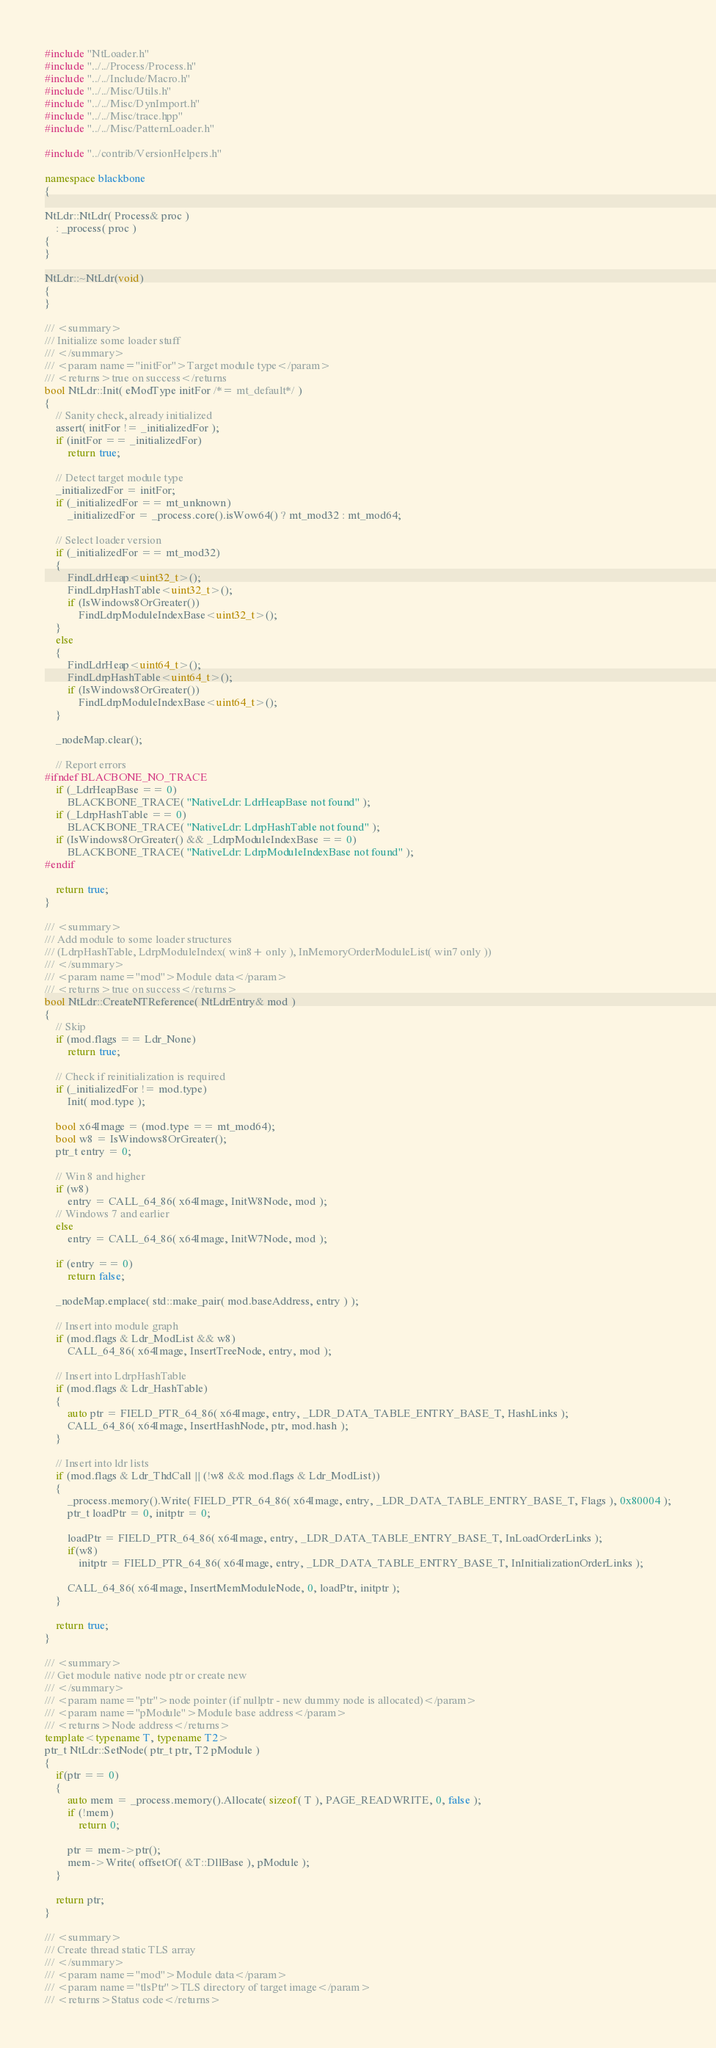Convert code to text. <code><loc_0><loc_0><loc_500><loc_500><_C++_>#include "NtLoader.h"
#include "../../Process/Process.h"
#include "../../Include/Macro.h"
#include "../../Misc/Utils.h"
#include "../../Misc/DynImport.h"
#include "../../Misc/trace.hpp"
#include "../../Misc/PatternLoader.h"

#include "../contrib/VersionHelpers.h"

namespace blackbone
{

NtLdr::NtLdr( Process& proc )
    : _process( proc )
{
}

NtLdr::~NtLdr(void)
{
}

/// <summary>
/// Initialize some loader stuff
/// </summary>
/// <param name="initFor">Target module type</param>
/// <returns>true on success</returns
bool NtLdr::Init( eModType initFor /*= mt_default*/ )
{
    // Sanity check, already initialized
    assert( initFor != _initializedFor );
    if (initFor == _initializedFor)
        return true;

    // Detect target module type
    _initializedFor = initFor;
    if (_initializedFor == mt_unknown)
        _initializedFor = _process.core().isWow64() ? mt_mod32 : mt_mod64;

    // Select loader version
    if (_initializedFor == mt_mod32)
    {
        FindLdrHeap<uint32_t>();
        FindLdrpHashTable<uint32_t>();
        if (IsWindows8OrGreater())
            FindLdrpModuleIndexBase<uint32_t>();
    }
    else
    {
        FindLdrHeap<uint64_t>();
        FindLdrpHashTable<uint64_t>();
        if (IsWindows8OrGreater())
            FindLdrpModuleIndexBase<uint64_t>();
    }

    _nodeMap.clear();

    // Report errors
#ifndef BLACBONE_NO_TRACE
    if (_LdrHeapBase == 0)
        BLACKBONE_TRACE( "NativeLdr: LdrHeapBase not found" );
    if (_LdrpHashTable == 0)
        BLACKBONE_TRACE( "NativeLdr: LdrpHashTable not found" );
    if (IsWindows8OrGreater() && _LdrpModuleIndexBase == 0)
        BLACKBONE_TRACE( "NativeLdr: LdrpModuleIndexBase not found" );
#endif

    return true;
}

/// <summary>
/// Add module to some loader structures 
/// (LdrpHashTable, LdrpModuleIndex( win8+ only ), InMemoryOrderModuleList( win7 only ))
/// </summary>
/// <param name="mod">Module data</param>
/// <returns>true on success</returns>
bool NtLdr::CreateNTReference( NtLdrEntry& mod )
{
    // Skip
    if (mod.flags == Ldr_None)
        return true;

    // Check if reinitialization is required
    if (_initializedFor != mod.type)
        Init( mod.type );

    bool x64Image = (mod.type == mt_mod64);
    bool w8 = IsWindows8OrGreater();
    ptr_t entry = 0;

    // Win 8 and higher
    if (w8)
        entry = CALL_64_86( x64Image, InitW8Node, mod );             
    // Windows 7 and earlier
    else
        entry = CALL_64_86( x64Image, InitW7Node, mod );

    if (entry == 0)
        return false;

    _nodeMap.emplace( std::make_pair( mod.baseAddress, entry ) );

    // Insert into module graph
    if (mod.flags & Ldr_ModList && w8)
        CALL_64_86( x64Image, InsertTreeNode, entry, mod );

    // Insert into LdrpHashTable
    if (mod.flags & Ldr_HashTable)
    {
        auto ptr = FIELD_PTR_64_86( x64Image, entry, _LDR_DATA_TABLE_ENTRY_BASE_T, HashLinks );
        CALL_64_86( x64Image, InsertHashNode, ptr, mod.hash );
    }

    // Insert into ldr lists
    if (mod.flags & Ldr_ThdCall || (!w8 && mod.flags & Ldr_ModList))
    {
        _process.memory().Write( FIELD_PTR_64_86( x64Image, entry, _LDR_DATA_TABLE_ENTRY_BASE_T, Flags ), 0x80004 );
        ptr_t loadPtr = 0, initptr = 0;

        loadPtr = FIELD_PTR_64_86( x64Image, entry, _LDR_DATA_TABLE_ENTRY_BASE_T, InLoadOrderLinks );
        if(w8)
            initptr = FIELD_PTR_64_86( x64Image, entry, _LDR_DATA_TABLE_ENTRY_BASE_T, InInitializationOrderLinks );

        CALL_64_86( x64Image, InsertMemModuleNode, 0, loadPtr, initptr );
    }

    return true;
}

/// <summary>
/// Get module native node ptr or create new
/// </summary>
/// <param name="ptr">node pointer (if nullptr - new dummy node is allocated)</param>
/// <param name="pModule">Module base address</param>
/// <returns>Node address</returns>
template<typename T, typename T2> 
ptr_t NtLdr::SetNode( ptr_t ptr, T2 pModule )
{
    if(ptr == 0)
    {
        auto mem = _process.memory().Allocate( sizeof( T ), PAGE_READWRITE, 0, false );
        if (!mem)
            return 0;

        ptr = mem->ptr();
        mem->Write( offsetOf( &T::DllBase ), pModule );
    }

    return ptr;
}

/// <summary>
/// Create thread static TLS array
/// </summary>
/// <param name="mod">Module data</param>
/// <param name="tlsPtr">TLS directory of target image</param>
/// <returns>Status code</returns></code> 